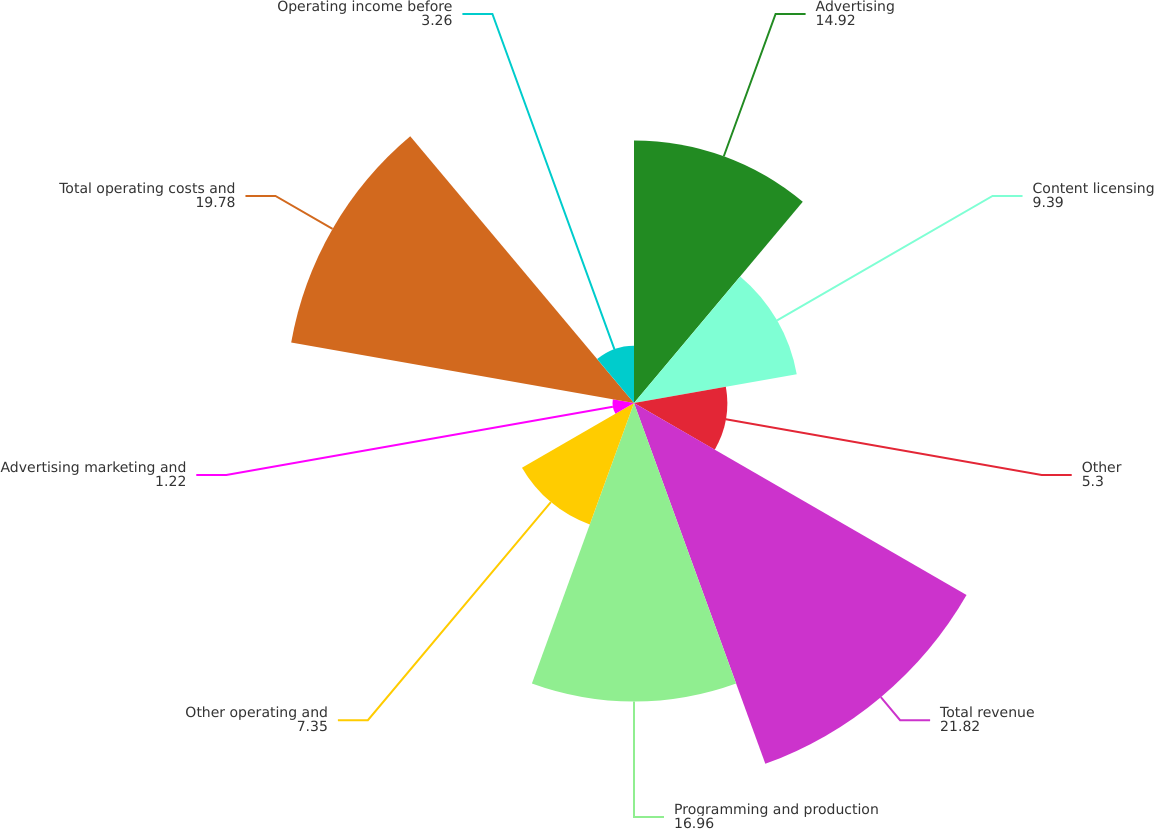Convert chart. <chart><loc_0><loc_0><loc_500><loc_500><pie_chart><fcel>Advertising<fcel>Content licensing<fcel>Other<fcel>Total revenue<fcel>Programming and production<fcel>Other operating and<fcel>Advertising marketing and<fcel>Total operating costs and<fcel>Operating income before<nl><fcel>14.92%<fcel>9.39%<fcel>5.3%<fcel>21.82%<fcel>16.96%<fcel>7.35%<fcel>1.22%<fcel>19.78%<fcel>3.26%<nl></chart> 